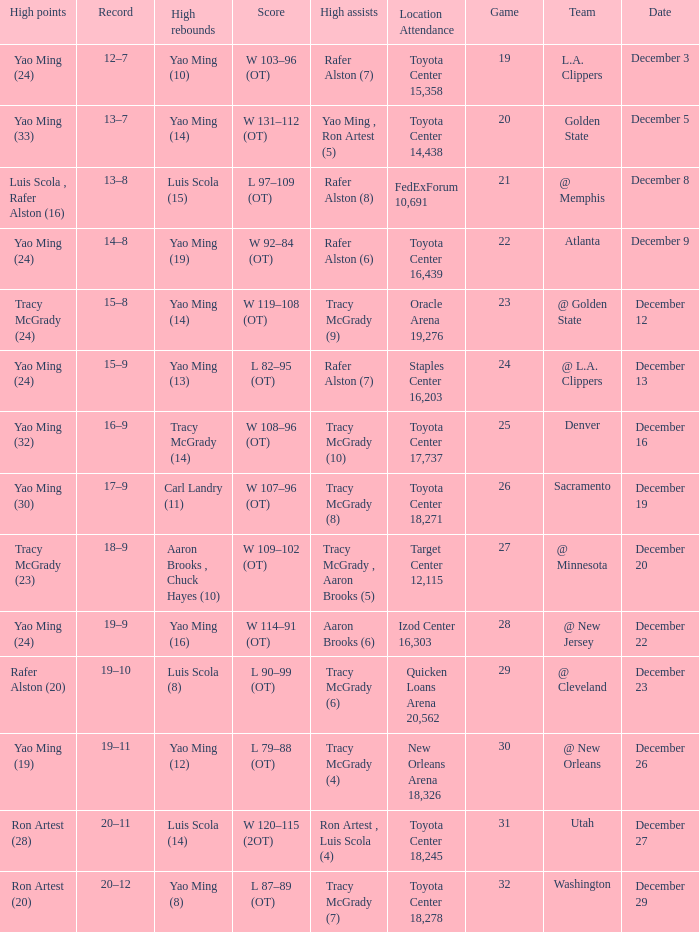When tracy mcgrady (8) is leading in assists what is the date? December 19. I'm looking to parse the entire table for insights. Could you assist me with that? {'header': ['High points', 'Record', 'High rebounds', 'Score', 'High assists', 'Location Attendance', 'Game', 'Team', 'Date'], 'rows': [['Yao Ming (24)', '12–7', 'Yao Ming (10)', 'W 103–96 (OT)', 'Rafer Alston (7)', 'Toyota Center 15,358', '19', 'L.A. Clippers', 'December 3'], ['Yao Ming (33)', '13–7', 'Yao Ming (14)', 'W 131–112 (OT)', 'Yao Ming , Ron Artest (5)', 'Toyota Center 14,438', '20', 'Golden State', 'December 5'], ['Luis Scola , Rafer Alston (16)', '13–8', 'Luis Scola (15)', 'L 97–109 (OT)', 'Rafer Alston (8)', 'FedExForum 10,691', '21', '@ Memphis', 'December 8'], ['Yao Ming (24)', '14–8', 'Yao Ming (19)', 'W 92–84 (OT)', 'Rafer Alston (6)', 'Toyota Center 16,439', '22', 'Atlanta', 'December 9'], ['Tracy McGrady (24)', '15–8', 'Yao Ming (14)', 'W 119–108 (OT)', 'Tracy McGrady (9)', 'Oracle Arena 19,276', '23', '@ Golden State', 'December 12'], ['Yao Ming (24)', '15–9', 'Yao Ming (13)', 'L 82–95 (OT)', 'Rafer Alston (7)', 'Staples Center 16,203', '24', '@ L.A. Clippers', 'December 13'], ['Yao Ming (32)', '16–9', 'Tracy McGrady (14)', 'W 108–96 (OT)', 'Tracy McGrady (10)', 'Toyota Center 17,737', '25', 'Denver', 'December 16'], ['Yao Ming (30)', '17–9', 'Carl Landry (11)', 'W 107–96 (OT)', 'Tracy McGrady (8)', 'Toyota Center 18,271', '26', 'Sacramento', 'December 19'], ['Tracy McGrady (23)', '18–9', 'Aaron Brooks , Chuck Hayes (10)', 'W 109–102 (OT)', 'Tracy McGrady , Aaron Brooks (5)', 'Target Center 12,115', '27', '@ Minnesota', 'December 20'], ['Yao Ming (24)', '19–9', 'Yao Ming (16)', 'W 114–91 (OT)', 'Aaron Brooks (6)', 'Izod Center 16,303', '28', '@ New Jersey', 'December 22'], ['Rafer Alston (20)', '19–10', 'Luis Scola (8)', 'L 90–99 (OT)', 'Tracy McGrady (6)', 'Quicken Loans Arena 20,562', '29', '@ Cleveland', 'December 23'], ['Yao Ming (19)', '19–11', 'Yao Ming (12)', 'L 79–88 (OT)', 'Tracy McGrady (4)', 'New Orleans Arena 18,326', '30', '@ New Orleans', 'December 26'], ['Ron Artest (28)', '20–11', 'Luis Scola (14)', 'W 120–115 (2OT)', 'Ron Artest , Luis Scola (4)', 'Toyota Center 18,245', '31', 'Utah', 'December 27'], ['Ron Artest (20)', '20–12', 'Yao Ming (8)', 'L 87–89 (OT)', 'Tracy McGrady (7)', 'Toyota Center 18,278', '32', 'Washington', 'December 29']]} 